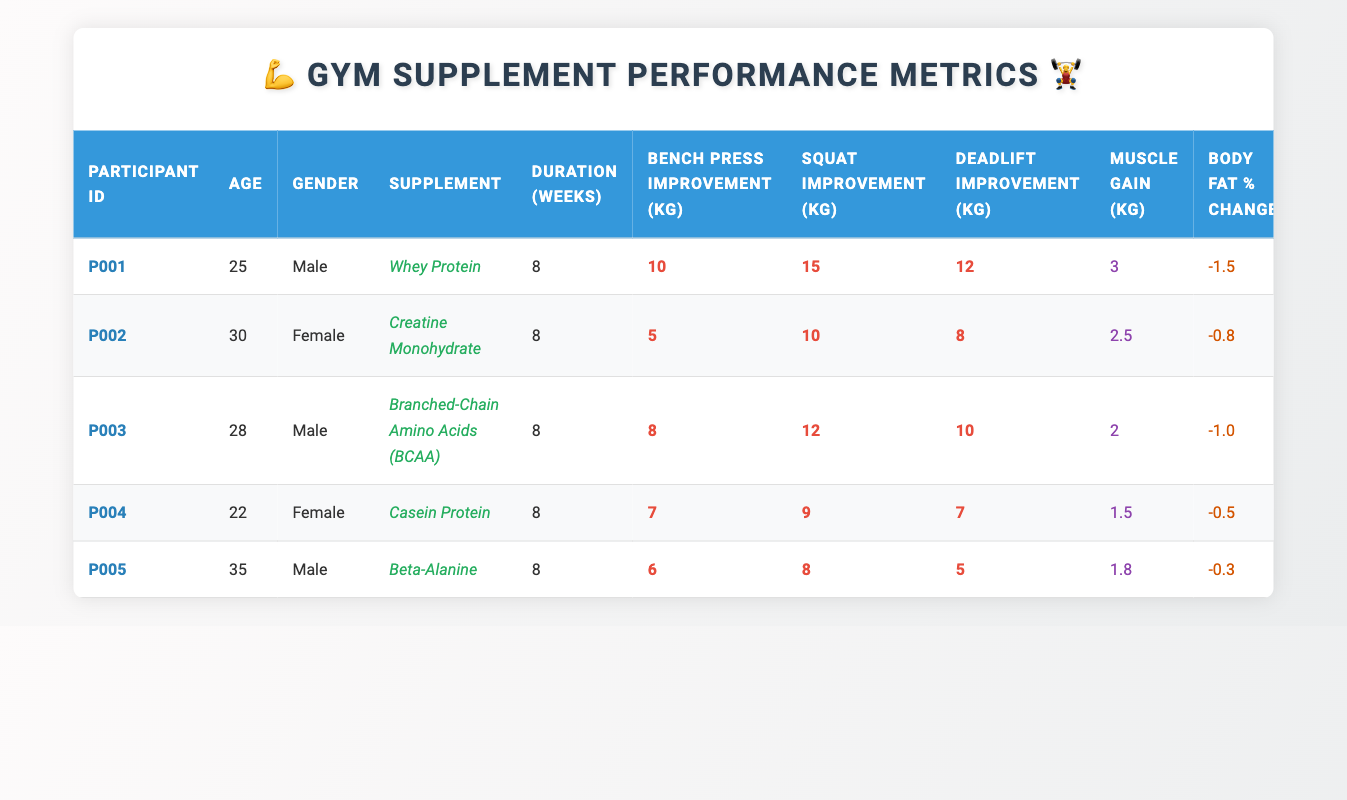What supplement did participant P001 take? Looking at the table, under the "Participant ID" column, the row for participant P001 lists "Whey Protein" in the "Supplement" column.
Answer: Whey Protein Which participant had the highest bench press improvement? By checking the "Bench Press Improvement (kg)" column, participant P001 shows an improvement of 10 kg, which is the highest among all participants listed.
Answer: P001 What was the average muscle gain among all participants? The muscle gains for all participants are 3, 2.5, 2, 1.5, and 1.8 kg. Summing these values gives 10.8 kg. Dividing by the number of participants (5), the average muscle gain is 10.8 kg / 5 = 2.16 kg.
Answer: 2.16 kg Did any participant increase their squat performance by more than 10 kg? Reviewing the "Squat Improvement (kg)" column, participants P001 and P002 achieved improvements of 15 kg and 10 kg, respectively. Participant P001 had the only improvement exceeding 10 kg.
Answer: Yes How much did the body fat percentage change for the participant with the least muscle gain? The participant with the least muscle gain is P004, with a muscle gain of 1.5 kg. In the "Body Fat % Change" column, P004's body fat percentage change is -0.5%.
Answer: -0.5% What is the combined improvement in deadlift for male participants? The deadlift improvements for male participants (P001, P003, P005) are 12 kg, 10 kg, and 5 kg, respectively. Their combined improvement is 12 + 10 + 5 = 27 kg.
Answer: 27 kg Did any participant who took creatine have a muscle gain of 3 kg or more? Participant P002, who took Creatine Monohydrate, had a muscle gain of 2.5 kg, which is less than 3 kg. Therefore, the answer is no.
Answer: No Which participant had the highest overall performance improvement across all metrics? Evaluating the improvements across all metrics (bench press, squat, deadlift) for each participant: P001 has 10 + 15 + 12 = 37 kg total improvement, which is the highest total compared to others.
Answer: P001 What effect did supplementation generally have on body fat percentage? The body fat percentage changes for all participants are -1.5, -0.8, -1.0, -0.5, and -0.3%. All values are negative, suggesting that supplementation generally resulted in reduced body fat percentage across the board.
Answer: Reduced body fat percentage for all participants 